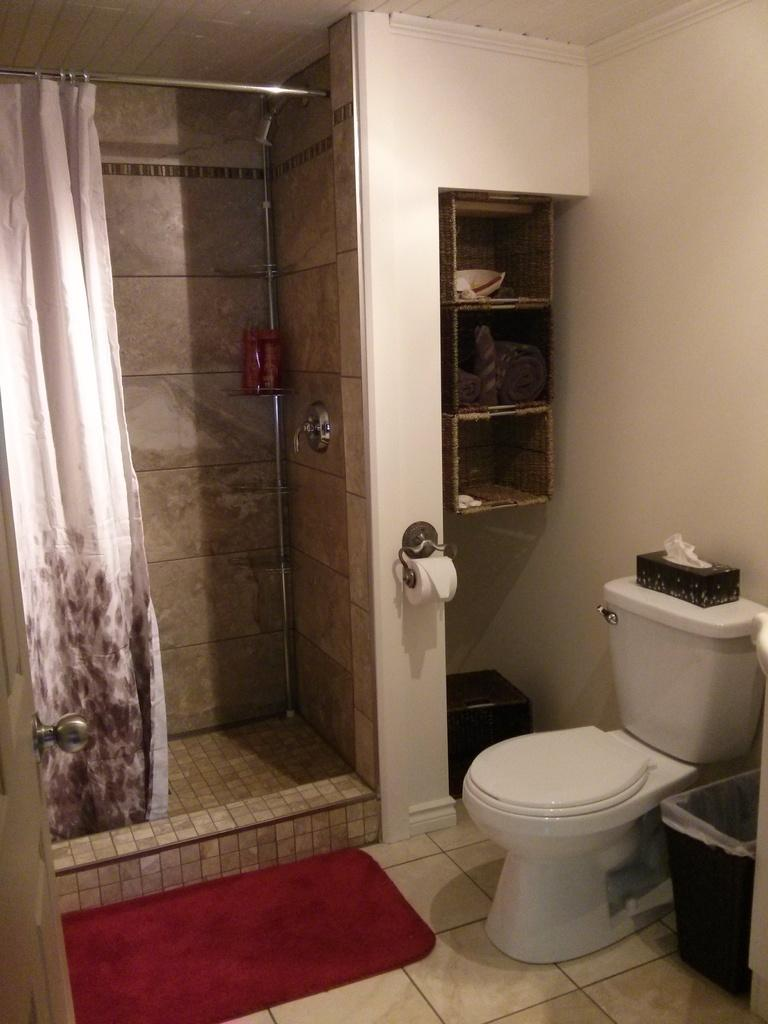What type of furniture is present in the image? There is a commode in the image. What can be used for storage in the image? There are shelves in the image. What type of window treatment is present in the image? There is a curtain in the image. What is used for disposing of waste in the image? There is a dustbin in the image. What can be used for wiping feet in the image? There is a mat in the image. What type of structure is visible in the image? There is a wall in the image. How many pigs are flying around the room in the image? There are no pigs present in the image, let alone flying around the room. 